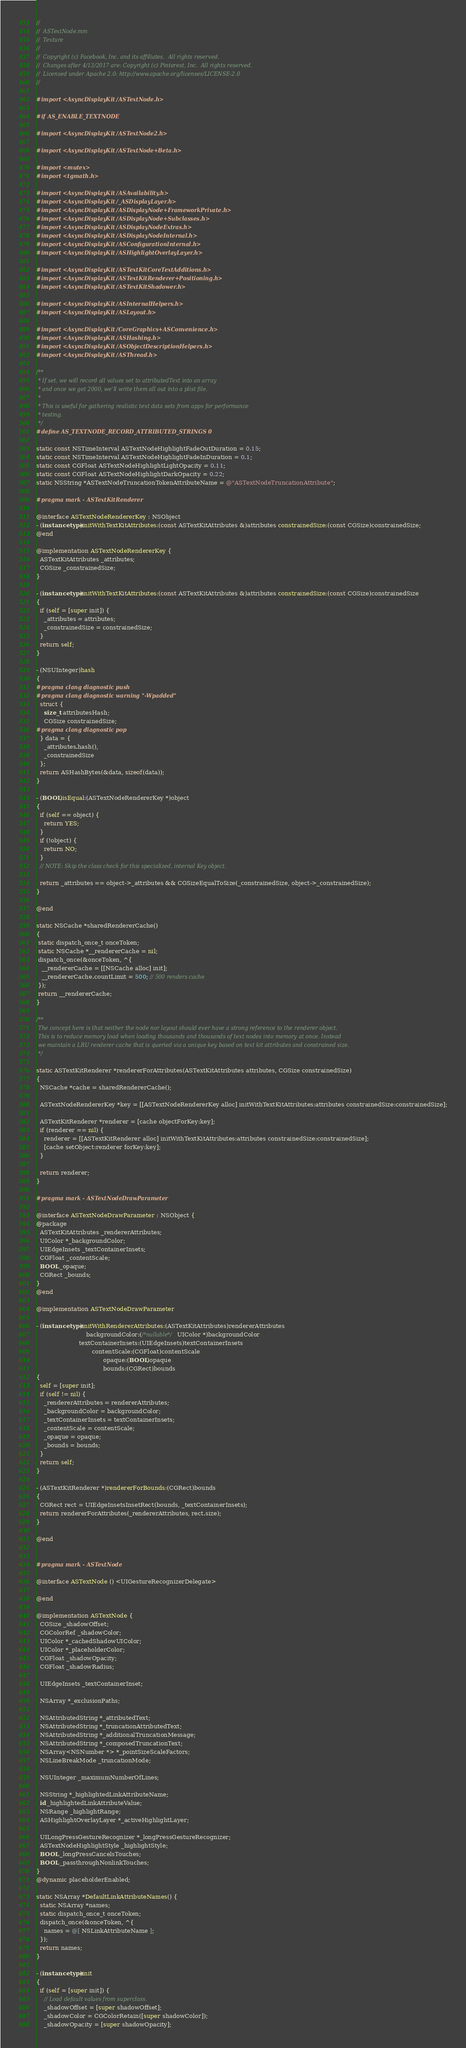<code> <loc_0><loc_0><loc_500><loc_500><_ObjectiveC_>//
//  ASTextNode.mm
//  Texture
//
//  Copyright (c) Facebook, Inc. and its affiliates.  All rights reserved.
//  Changes after 4/13/2017 are: Copyright (c) Pinterest, Inc.  All rights reserved.
//  Licensed under Apache 2.0: http://www.apache.org/licenses/LICENSE-2.0
//

#import <AsyncDisplayKit/ASTextNode.h>

#if AS_ENABLE_TEXTNODE

#import <AsyncDisplayKit/ASTextNode2.h>

#import <AsyncDisplayKit/ASTextNode+Beta.h>

#import <mutex>
#import <tgmath.h>

#import <AsyncDisplayKit/ASAvailability.h>
#import <AsyncDisplayKit/_ASDisplayLayer.h>
#import <AsyncDisplayKit/ASDisplayNode+FrameworkPrivate.h>
#import <AsyncDisplayKit/ASDisplayNode+Subclasses.h>
#import <AsyncDisplayKit/ASDisplayNodeExtras.h>
#import <AsyncDisplayKit/ASDisplayNodeInternal.h>
#import <AsyncDisplayKit/ASConfigurationInternal.h>
#import <AsyncDisplayKit/ASHighlightOverlayLayer.h>

#import <AsyncDisplayKit/ASTextKitCoreTextAdditions.h>
#import <AsyncDisplayKit/ASTextKitRenderer+Positioning.h>
#import <AsyncDisplayKit/ASTextKitShadower.h>

#import <AsyncDisplayKit/ASInternalHelpers.h>
#import <AsyncDisplayKit/ASLayout.h>

#import <AsyncDisplayKit/CoreGraphics+ASConvenience.h>
#import <AsyncDisplayKit/ASHashing.h>
#import <AsyncDisplayKit/ASObjectDescriptionHelpers.h>
#import <AsyncDisplayKit/ASThread.h>

/**
 * If set, we will record all values set to attributedText into an array
 * and once we get 2000, we'll write them all out into a plist file.
 *
 * This is useful for gathering realistic text data sets from apps for performance
 * testing.
 */
#define AS_TEXTNODE_RECORD_ATTRIBUTED_STRINGS 0

static const NSTimeInterval ASTextNodeHighlightFadeOutDuration = 0.15;
static const NSTimeInterval ASTextNodeHighlightFadeInDuration = 0.1;
static const CGFloat ASTextNodeHighlightLightOpacity = 0.11;
static const CGFloat ASTextNodeHighlightDarkOpacity = 0.22;
static NSString *ASTextNodeTruncationTokenAttributeName = @"ASTextNodeTruncationAttribute";

#pragma mark - ASTextKitRenderer

@interface ASTextNodeRendererKey : NSObject
- (instancetype)initWithTextKitAttributes:(const ASTextKitAttributes &)attributes constrainedSize:(const CGSize)constrainedSize;
@end

@implementation ASTextNodeRendererKey {
  ASTextKitAttributes _attributes;
  CGSize _constrainedSize;
}

- (instancetype)initWithTextKitAttributes:(const ASTextKitAttributes &)attributes constrainedSize:(const CGSize)constrainedSize
{
  if (self = [super init]) {
    _attributes = attributes;
    _constrainedSize = constrainedSize;
  }
  return self;
}

- (NSUInteger)hash
{
#pragma clang diagnostic push
#pragma clang diagnostic warning "-Wpadded"
  struct {
    size_t attributesHash;
    CGSize constrainedSize;
#pragma clang diagnostic pop
  } data = {
    _attributes.hash(),
    _constrainedSize
  };
  return ASHashBytes(&data, sizeof(data));
}

- (BOOL)isEqual:(ASTextNodeRendererKey *)object
{
  if (self == object) {
    return YES;
  }
  if (!object) {
    return NO;
  }
  // NOTE: Skip the class check for this specialized, internal Key object.
  
  return _attributes == object->_attributes && CGSizeEqualToSize(_constrainedSize, object->_constrainedSize);
}

@end

static NSCache *sharedRendererCache()
{ 
 static dispatch_once_t onceToken;
 static NSCache *__rendererCache = nil;
 dispatch_once(&onceToken, ^{
   __rendererCache = [[NSCache alloc] init];
   __rendererCache.countLimit = 500; // 500 renders cache
 });
 return __rendererCache;
}

/**
 The concept here is that neither the node nor layout should ever have a strong reference to the renderer object.
 This is to reduce memory load when loading thousands and thousands of text nodes into memory at once. Instead
 we maintain a LRU renderer cache that is queried via a unique key based on text kit attributes and constrained size. 
 */

static ASTextKitRenderer *rendererForAttributes(ASTextKitAttributes attributes, CGSize constrainedSize)
{
  NSCache *cache = sharedRendererCache();
  
  ASTextNodeRendererKey *key = [[ASTextNodeRendererKey alloc] initWithTextKitAttributes:attributes constrainedSize:constrainedSize];

  ASTextKitRenderer *renderer = [cache objectForKey:key];
  if (renderer == nil) {
    renderer = [[ASTextKitRenderer alloc] initWithTextKitAttributes:attributes constrainedSize:constrainedSize];
    [cache setObject:renderer forKey:key];
  }
  
  return renderer;
}

#pragma mark - ASTextNodeDrawParameter

@interface ASTextNodeDrawParameter : NSObject {
@package
  ASTextKitAttributes _rendererAttributes;
  UIColor *_backgroundColor;
  UIEdgeInsets _textContainerInsets;
  CGFloat _contentScale;
  BOOL _opaque;
  CGRect _bounds;
}
@end

@implementation ASTextNodeDrawParameter

- (instancetype)initWithRendererAttributes:(ASTextKitAttributes)rendererAttributes
                           backgroundColor:(/*nullable*/ UIColor *)backgroundColor
                       textContainerInsets:(UIEdgeInsets)textContainerInsets
                              contentScale:(CGFloat)contentScale
                                    opaque:(BOOL)opaque
                                    bounds:(CGRect)bounds
{
  self = [super init];
  if (self != nil) {
    _rendererAttributes = rendererAttributes;
    _backgroundColor = backgroundColor;
    _textContainerInsets = textContainerInsets;
    _contentScale = contentScale;
    _opaque = opaque;
    _bounds = bounds;
  }
  return self;
}

- (ASTextKitRenderer *)rendererForBounds:(CGRect)bounds
{
  CGRect rect = UIEdgeInsetsInsetRect(bounds, _textContainerInsets);
  return rendererForAttributes(_rendererAttributes, rect.size);
}

@end


#pragma mark - ASTextNode

@interface ASTextNode () <UIGestureRecognizerDelegate>

@end

@implementation ASTextNode {
  CGSize _shadowOffset;
  CGColorRef _shadowColor;
  UIColor *_cachedShadowUIColor;
  UIColor *_placeholderColor;
  CGFloat _shadowOpacity;
  CGFloat _shadowRadius;
  
  UIEdgeInsets _textContainerInset;

  NSArray *_exclusionPaths;

  NSAttributedString *_attributedText;
  NSAttributedString *_truncationAttributedText;
  NSAttributedString *_additionalTruncationMessage;
  NSAttributedString *_composedTruncationText;
  NSArray<NSNumber *> *_pointSizeScaleFactors;
  NSLineBreakMode _truncationMode;
  
  NSUInteger _maximumNumberOfLines;

  NSString *_highlightedLinkAttributeName;
  id _highlightedLinkAttributeValue;
  NSRange _highlightRange;
  ASHighlightOverlayLayer *_activeHighlightLayer;

  UILongPressGestureRecognizer *_longPressGestureRecognizer;
  ASTextNodeHighlightStyle _highlightStyle;
  BOOL _longPressCancelsTouches;
  BOOL _passthroughNonlinkTouches;
}
@dynamic placeholderEnabled;

static NSArray *DefaultLinkAttributeNames() {
  static NSArray *names;
  static dispatch_once_t onceToken;
  dispatch_once(&onceToken, ^{
    names = @[ NSLinkAttributeName ];
  });
  return names;
}

- (instancetype)init
{
  if (self = [super init]) {
    // Load default values from superclass.
    _shadowOffset = [super shadowOffset];
    _shadowColor = CGColorRetain([super shadowColor]);
    _shadowOpacity = [super shadowOpacity];</code> 